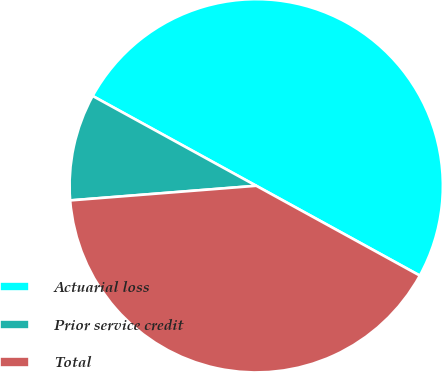Convert chart. <chart><loc_0><loc_0><loc_500><loc_500><pie_chart><fcel>Actuarial loss<fcel>Prior service credit<fcel>Total<nl><fcel>50.0%<fcel>9.24%<fcel>40.76%<nl></chart> 